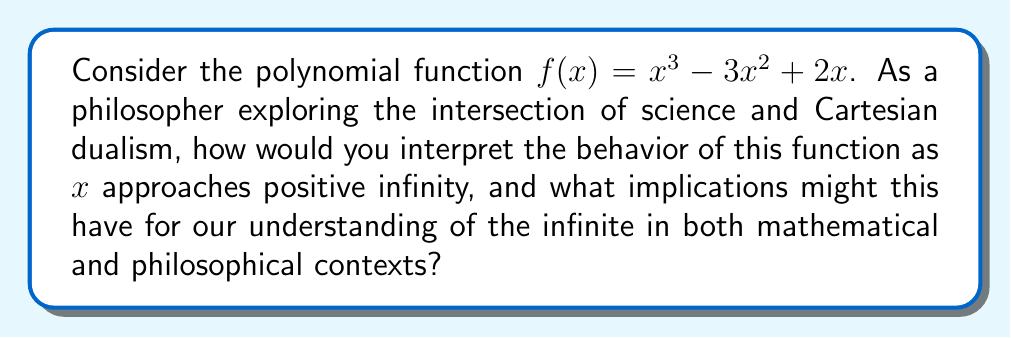Could you help me with this problem? To analyze the behavior of $f(x) = x^3 - 3x^2 + 2x$ as $x$ approaches positive infinity, we can follow these steps:

1) First, let's consider the degrees of the terms in the polynomial:
   $x^3$ has degree 3
   $-3x^2$ has degree 2
   $2x$ has degree 1

2) As $x$ becomes very large, the term with the highest degree will dominate the function's behavior. In this case, it's $x^3$.

3) We can verify this by dividing the function by $x^3$:

   $$\lim_{x \to \infty} \frac{f(x)}{x^3} = \lim_{x \to \infty} \frac{x^3 - 3x^2 + 2x}{x^3} = \lim_{x \to \infty} (1 - \frac{3}{x} + \frac{2}{x^2}) = 1$$

4) This means that as $x$ approaches infinity, $f(x)$ behaves like $x^3$.

5) Therefore, $\lim_{x \to \infty} f(x) = \infty$

From a philosophical perspective, this behavior illustrates several key points:

a) The concept of infinity in mathematics is not a fixed value but a process of unbounded growth.

b) The polynomial, despite being a finite expression, can represent an infinite concept.

c) The dominance of the highest degree term shows how in the realm of the infinite, certain aspects can overshadow others, potentially relating to the idea of emergent properties in complex systems.

d) The polynomial's behavior at infinity is determined by its structure, which could be seen as an analogy to how the nature of reality might be determined by underlying mathematical or logical structures, a view compatible with certain interpretations of Cartesian dualism.

e) The fact that we can reason about infinity using finite mathematical objects might suggest a bridge between the finite physical world and the infinite realm of ideas or consciousness in dualist philosophy.
Answer: As $x$ approaches positive infinity, $f(x)$ approaches positive infinity, dominated by its cubic term. This illustrates infinity as an unbounded process, bridging finite representations with infinite concepts, potentially informing dualist perspectives on reality's structure. 